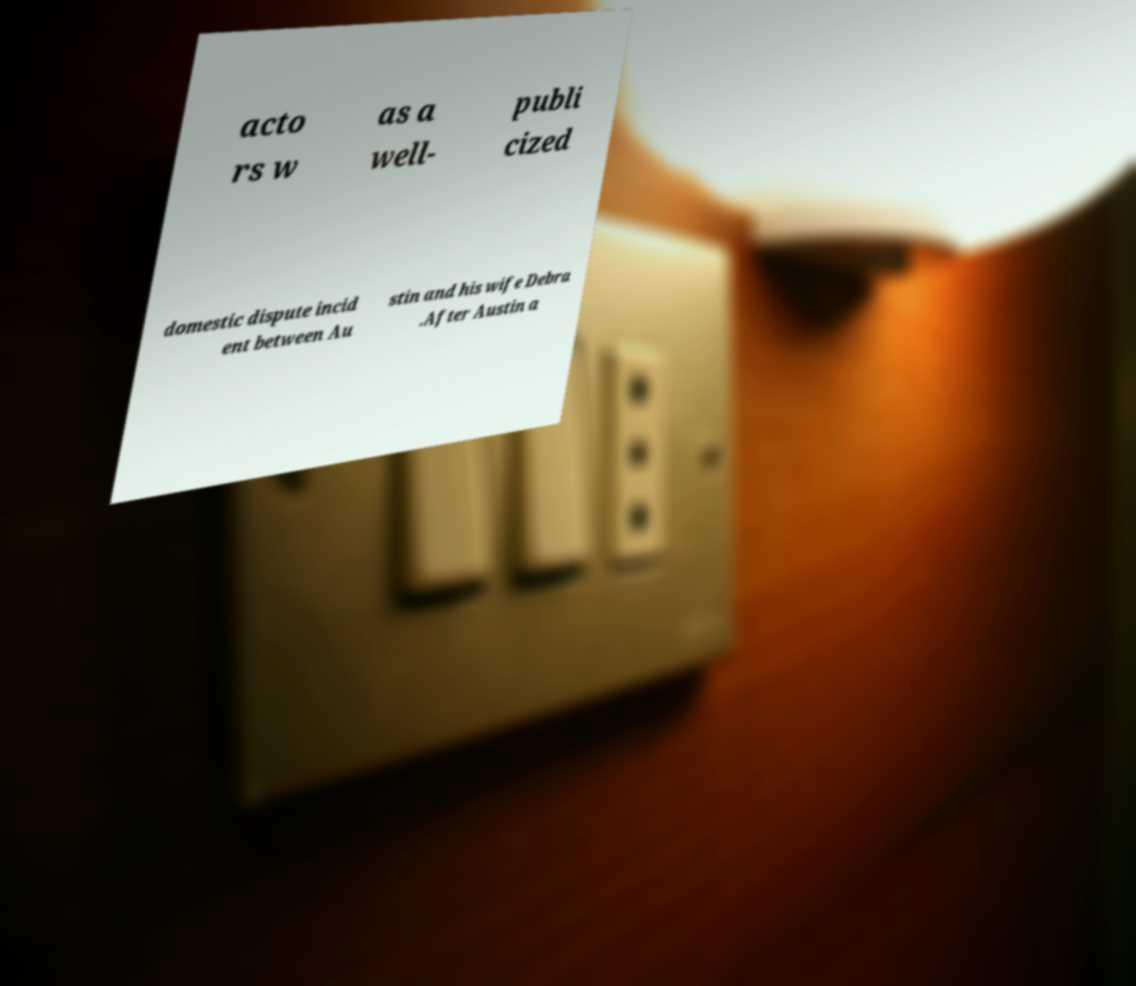Could you extract and type out the text from this image? acto rs w as a well- publi cized domestic dispute incid ent between Au stin and his wife Debra .After Austin a 